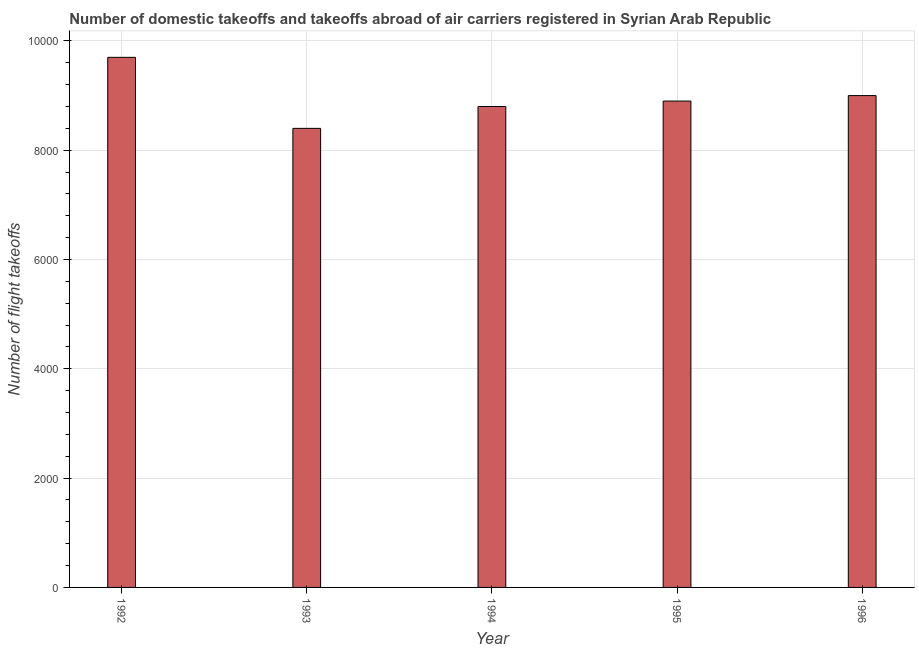What is the title of the graph?
Keep it short and to the point. Number of domestic takeoffs and takeoffs abroad of air carriers registered in Syrian Arab Republic. What is the label or title of the X-axis?
Offer a very short reply. Year. What is the label or title of the Y-axis?
Your answer should be very brief. Number of flight takeoffs. What is the number of flight takeoffs in 1993?
Your answer should be compact. 8400. Across all years, what is the maximum number of flight takeoffs?
Keep it short and to the point. 9700. Across all years, what is the minimum number of flight takeoffs?
Provide a succinct answer. 8400. In which year was the number of flight takeoffs maximum?
Offer a terse response. 1992. What is the sum of the number of flight takeoffs?
Ensure brevity in your answer.  4.48e+04. What is the difference between the number of flight takeoffs in 1993 and 1995?
Offer a very short reply. -500. What is the average number of flight takeoffs per year?
Make the answer very short. 8960. What is the median number of flight takeoffs?
Offer a terse response. 8900. In how many years, is the number of flight takeoffs greater than 6800 ?
Your answer should be very brief. 5. What is the ratio of the number of flight takeoffs in 1992 to that in 1996?
Your answer should be very brief. 1.08. Is the number of flight takeoffs in 1993 less than that in 1994?
Keep it short and to the point. Yes. Is the difference between the number of flight takeoffs in 1993 and 1996 greater than the difference between any two years?
Keep it short and to the point. No. What is the difference between the highest and the second highest number of flight takeoffs?
Make the answer very short. 700. Is the sum of the number of flight takeoffs in 1994 and 1996 greater than the maximum number of flight takeoffs across all years?
Ensure brevity in your answer.  Yes. What is the difference between the highest and the lowest number of flight takeoffs?
Your answer should be very brief. 1300. How many bars are there?
Make the answer very short. 5. How many years are there in the graph?
Give a very brief answer. 5. What is the difference between two consecutive major ticks on the Y-axis?
Your response must be concise. 2000. What is the Number of flight takeoffs of 1992?
Your answer should be very brief. 9700. What is the Number of flight takeoffs in 1993?
Offer a very short reply. 8400. What is the Number of flight takeoffs of 1994?
Ensure brevity in your answer.  8800. What is the Number of flight takeoffs in 1995?
Provide a succinct answer. 8900. What is the Number of flight takeoffs of 1996?
Provide a short and direct response. 9000. What is the difference between the Number of flight takeoffs in 1992 and 1993?
Provide a short and direct response. 1300. What is the difference between the Number of flight takeoffs in 1992 and 1994?
Make the answer very short. 900. What is the difference between the Number of flight takeoffs in 1992 and 1995?
Keep it short and to the point. 800. What is the difference between the Number of flight takeoffs in 1992 and 1996?
Offer a terse response. 700. What is the difference between the Number of flight takeoffs in 1993 and 1994?
Give a very brief answer. -400. What is the difference between the Number of flight takeoffs in 1993 and 1995?
Keep it short and to the point. -500. What is the difference between the Number of flight takeoffs in 1993 and 1996?
Your response must be concise. -600. What is the difference between the Number of flight takeoffs in 1994 and 1995?
Provide a short and direct response. -100. What is the difference between the Number of flight takeoffs in 1994 and 1996?
Offer a very short reply. -200. What is the difference between the Number of flight takeoffs in 1995 and 1996?
Ensure brevity in your answer.  -100. What is the ratio of the Number of flight takeoffs in 1992 to that in 1993?
Your answer should be very brief. 1.16. What is the ratio of the Number of flight takeoffs in 1992 to that in 1994?
Your answer should be compact. 1.1. What is the ratio of the Number of flight takeoffs in 1992 to that in 1995?
Provide a succinct answer. 1.09. What is the ratio of the Number of flight takeoffs in 1992 to that in 1996?
Offer a very short reply. 1.08. What is the ratio of the Number of flight takeoffs in 1993 to that in 1994?
Keep it short and to the point. 0.95. What is the ratio of the Number of flight takeoffs in 1993 to that in 1995?
Make the answer very short. 0.94. What is the ratio of the Number of flight takeoffs in 1993 to that in 1996?
Your answer should be compact. 0.93. What is the ratio of the Number of flight takeoffs in 1994 to that in 1996?
Keep it short and to the point. 0.98. What is the ratio of the Number of flight takeoffs in 1995 to that in 1996?
Offer a very short reply. 0.99. 